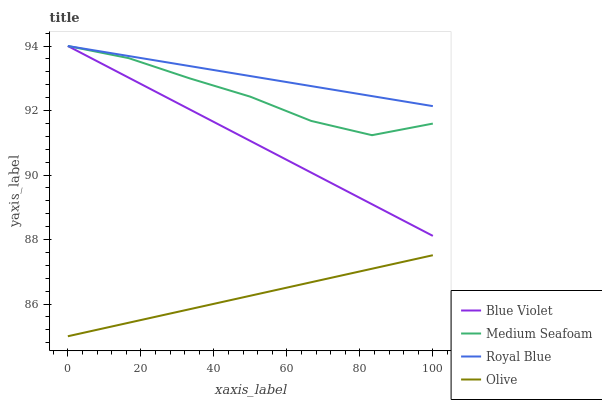Does Olive have the minimum area under the curve?
Answer yes or no. Yes. Does Royal Blue have the maximum area under the curve?
Answer yes or no. Yes. Does Medium Seafoam have the minimum area under the curve?
Answer yes or no. No. Does Medium Seafoam have the maximum area under the curve?
Answer yes or no. No. Is Blue Violet the smoothest?
Answer yes or no. Yes. Is Medium Seafoam the roughest?
Answer yes or no. Yes. Is Royal Blue the smoothest?
Answer yes or no. No. Is Royal Blue the roughest?
Answer yes or no. No. Does Olive have the lowest value?
Answer yes or no. Yes. Does Medium Seafoam have the lowest value?
Answer yes or no. No. Does Blue Violet have the highest value?
Answer yes or no. Yes. Is Olive less than Blue Violet?
Answer yes or no. Yes. Is Medium Seafoam greater than Olive?
Answer yes or no. Yes. Does Royal Blue intersect Blue Violet?
Answer yes or no. Yes. Is Royal Blue less than Blue Violet?
Answer yes or no. No. Is Royal Blue greater than Blue Violet?
Answer yes or no. No. Does Olive intersect Blue Violet?
Answer yes or no. No. 